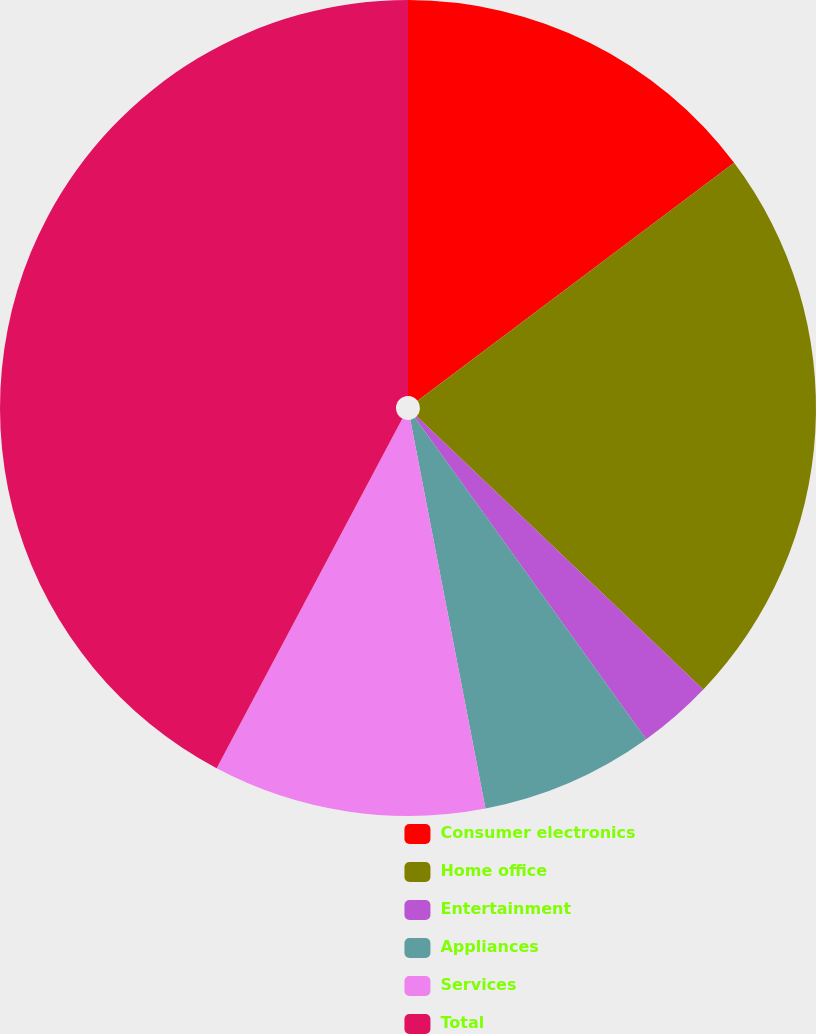Convert chart. <chart><loc_0><loc_0><loc_500><loc_500><pie_chart><fcel>Consumer electronics<fcel>Home office<fcel>Entertainment<fcel>Appliances<fcel>Services<fcel>Total<nl><fcel>14.74%<fcel>22.38%<fcel>2.96%<fcel>6.88%<fcel>10.81%<fcel>42.23%<nl></chart> 